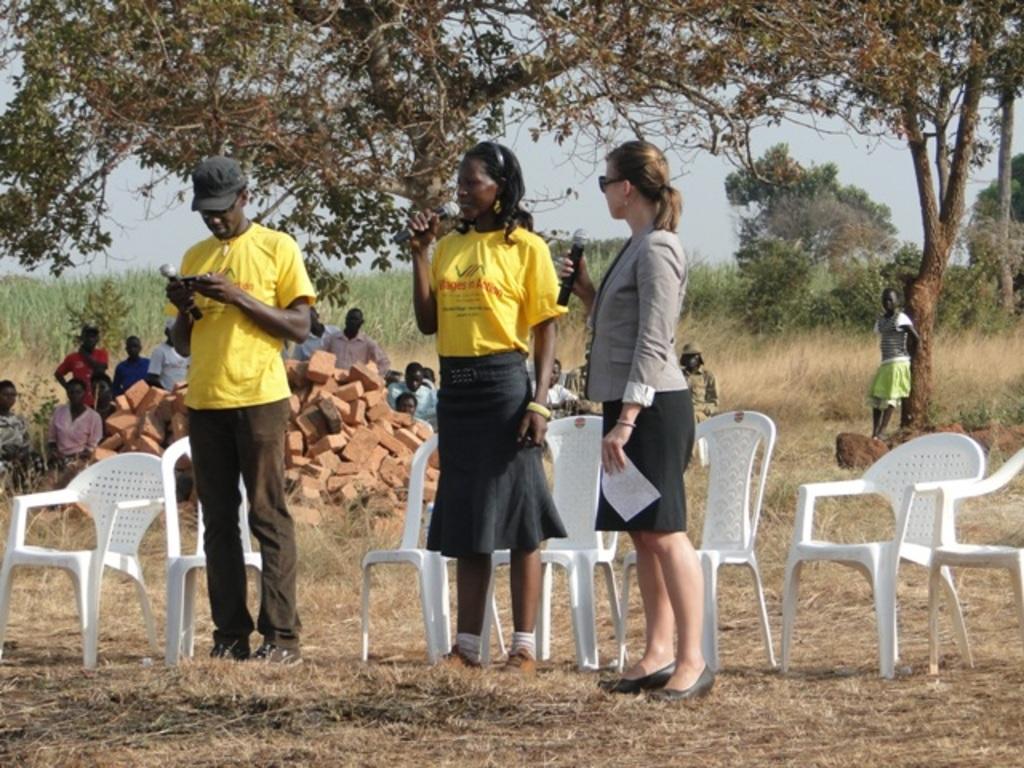Could you give a brief overview of what you see in this image? This image is taken in the outside of the city where there are person standing and sitting. The woman at the right side is holding mic in her hand and holding a paper in hand. In the center woman wearing yellow colour t-shirt is holding mic and is speaking. At the right side man holding mic and mobile phone in his hand is standing. There are empty chairs, in the background there are trees, sky, bricks and the person sitting and standing. 